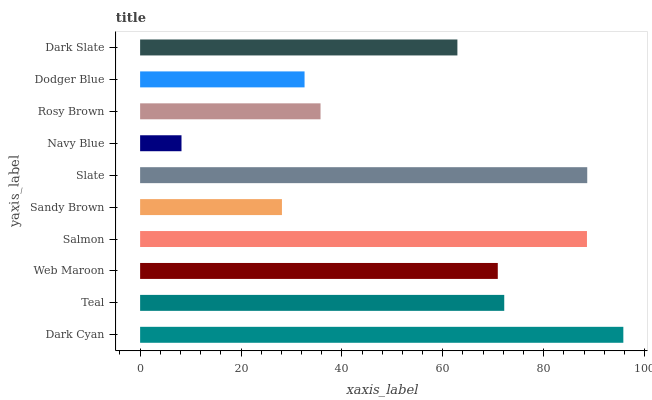Is Navy Blue the minimum?
Answer yes or no. Yes. Is Dark Cyan the maximum?
Answer yes or no. Yes. Is Teal the minimum?
Answer yes or no. No. Is Teal the maximum?
Answer yes or no. No. Is Dark Cyan greater than Teal?
Answer yes or no. Yes. Is Teal less than Dark Cyan?
Answer yes or no. Yes. Is Teal greater than Dark Cyan?
Answer yes or no. No. Is Dark Cyan less than Teal?
Answer yes or no. No. Is Web Maroon the high median?
Answer yes or no. Yes. Is Dark Slate the low median?
Answer yes or no. Yes. Is Sandy Brown the high median?
Answer yes or no. No. Is Slate the low median?
Answer yes or no. No. 